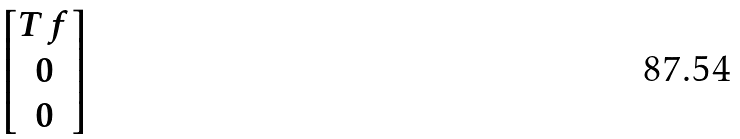Convert formula to latex. <formula><loc_0><loc_0><loc_500><loc_500>\begin{bmatrix} T f \\ 0 \\ 0 \end{bmatrix}</formula> 